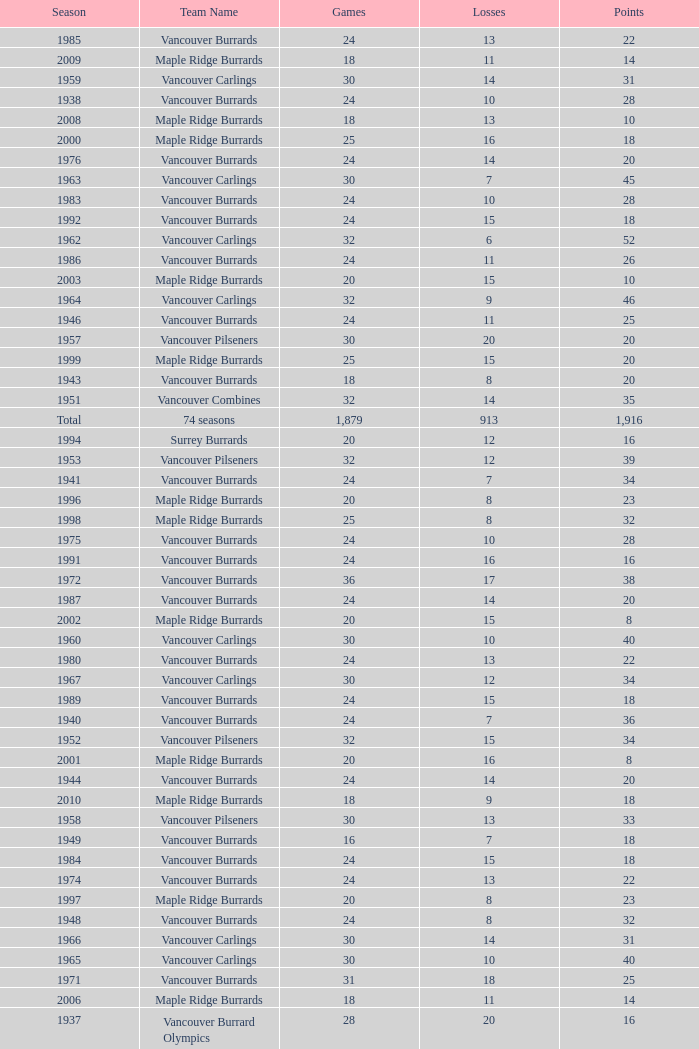What's the sum of points for the 1963 season when there are more than 30 games? None. 